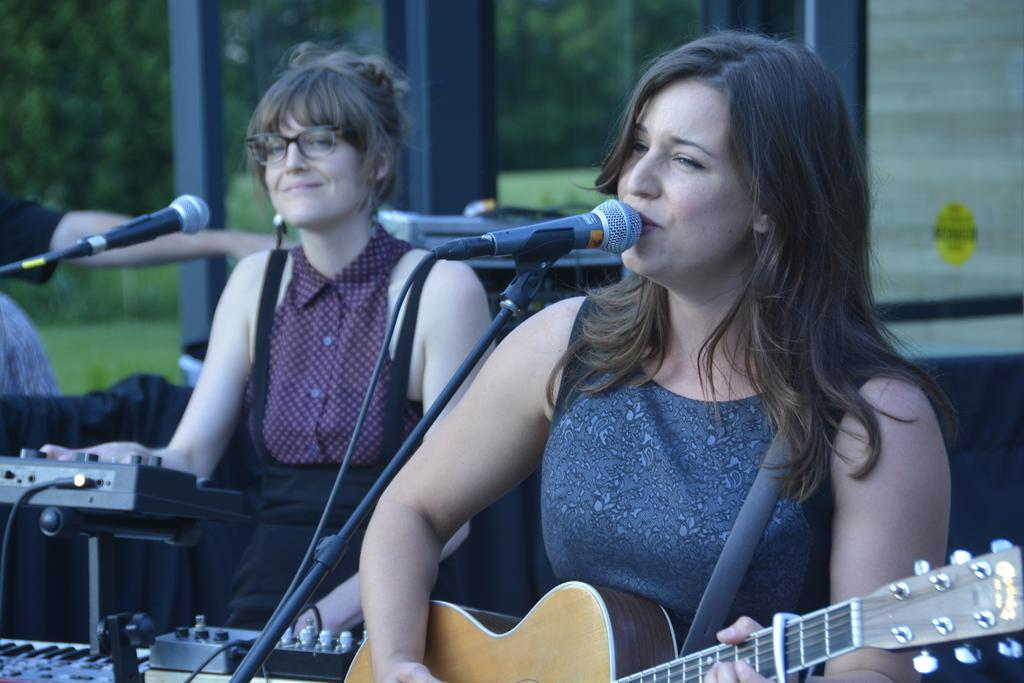What type of vegetation can be seen in the image? There are trees in the image. What are the people in the image doing? The people are sitting on chairs in the image. What object is the person holding in the image? The person is holding a guitar in the image. What activity is the person with the guitar engaged in? The person holding the guitar is singing into a microphone. What color is the copper rain falling on the trees in the image? There is no copper rain present in the image; it features trees, people sitting on chairs, a person holding a guitar, and the person singing into a microphone. How many oranges are visible on the trees in the image? There are no oranges present on the trees in the image. 